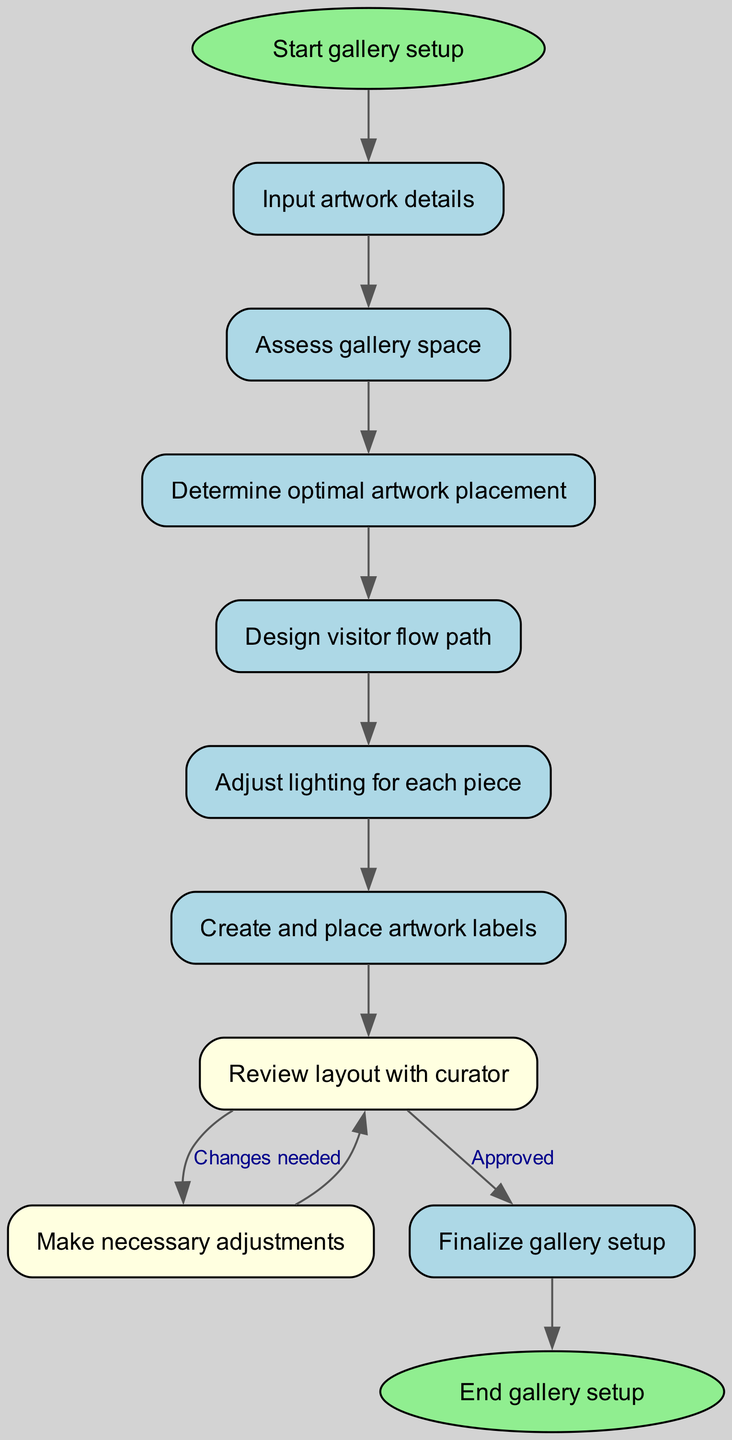What is the starting point of the flowchart? The flowchart starts with the "Start gallery setup" node, indicating the initiation of the process.
Answer: Start gallery setup How many nodes are present in the diagram? By counting the nodes listed in the data, there are a total of 11 nodes included in the flowchart.
Answer: 11 What is the first step after inputting artwork details? After the "Input artwork details" step, the flow proceeds to the "Assess gallery space" step as indicated by the edge connection.
Answer: Assess gallery space What type of node is "review"? The "review" node is colored light yellow, representing its role in the flowchart and indicating it involves evaluation.
Answer: Light yellow What action follows after the "Placement" node? The action that follows the "Placement" node is to "Design visitor flow path," indicating that placement leads directly to visitor flow design.
Answer: Design visitor flow path What happens if changes are needed after the review? If changes are needed, the flowchart indicates a return back to the "Adjust" node from the "Review" node, allowing for modifications before re-evaluation.
Answer: Make necessary adjustments How does the diagram indicate approval in the review process? The diagram shows the flow from "Review" to "Finalize" is marked as "Approved," which indicates the outcome of the review process is positive.
Answer: Approved What is the final step in the gallery setup process? The final step in the diagram is the "End gallery setup" node, which marks the completion of the gallery setup process.
Answer: End gallery setup Which two nodes are connected with a feedback loop? The feedback loop occurs between the "Review" node and the "Adjust" node, indicating a repeated process based on the review outcome.
Answer: Review and Adjust How many edges are leading out from the "review" node? There are two edges leading out from the "review" node; one goes to "adjust" when changes are needed, and the other goes to "finalize" when approved.
Answer: 2 